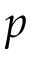Convert formula to latex. <formula><loc_0><loc_0><loc_500><loc_500>p</formula> 